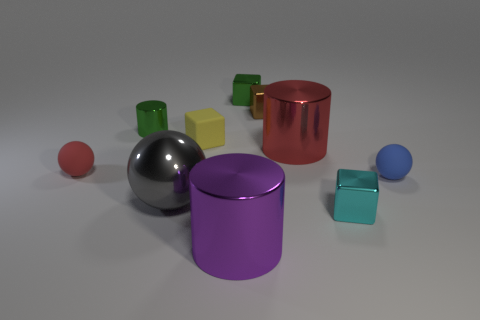What number of objects are either tiny brown metallic cubes or things behind the brown object?
Make the answer very short. 2. What size is the cyan cube that is the same material as the large gray sphere?
Your answer should be compact. Small. There is a red thing that is on the right side of the tiny matte ball behind the tiny blue ball; what shape is it?
Provide a short and direct response. Cylinder. There is a block that is both in front of the brown thing and left of the cyan object; what is its size?
Your response must be concise. Small. Is there another metal object of the same shape as the large purple object?
Your response must be concise. Yes. Is there anything else that is the same shape as the tiny red matte object?
Keep it short and to the point. Yes. What is the material of the green thing to the right of the big metal object in front of the small block that is in front of the metallic ball?
Provide a short and direct response. Metal. Are there any purple metallic cylinders that have the same size as the red rubber ball?
Make the answer very short. No. There is a metal cylinder in front of the small metal thing to the right of the large red thing; what color is it?
Make the answer very short. Purple. How many big gray shiny cylinders are there?
Offer a terse response. 0. 